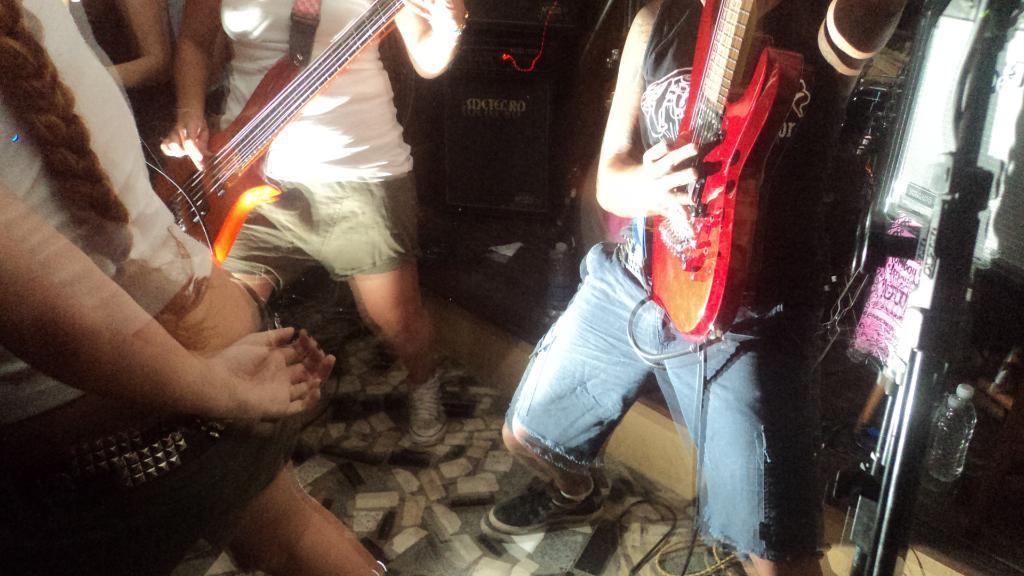Describe this image in one or two sentences. In this image i can see few persons holding musical instruments and playing 